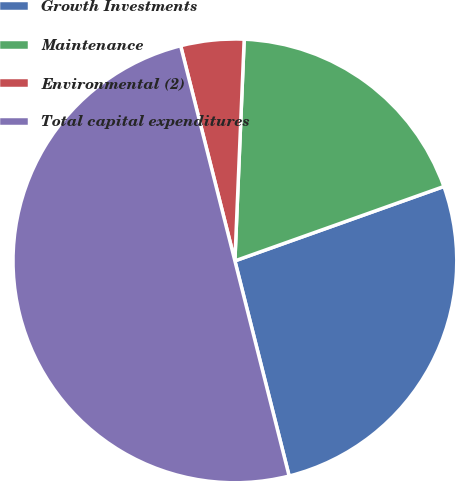<chart> <loc_0><loc_0><loc_500><loc_500><pie_chart><fcel>Growth Investments<fcel>Maintenance<fcel>Environmental (2)<fcel>Total capital expenditures<nl><fcel>26.51%<fcel>18.89%<fcel>4.6%<fcel>50.0%<nl></chart> 